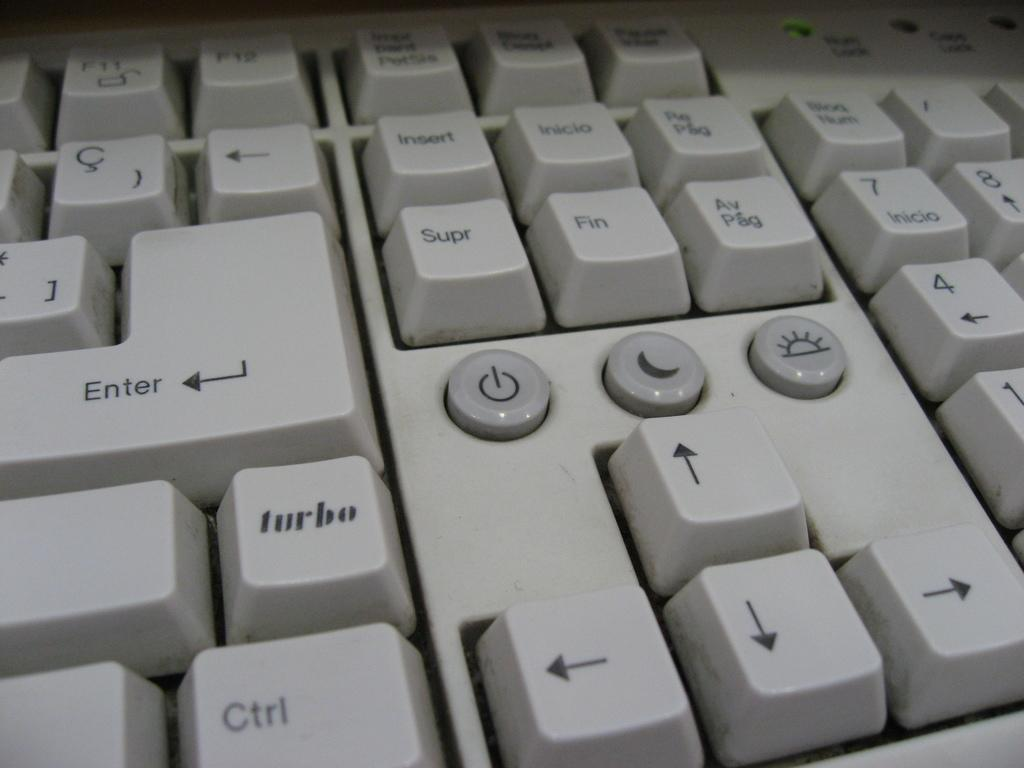Provide a one-sentence caption for the provided image. The Turbo button is located directly beneath the Enter button on the keyboard. 